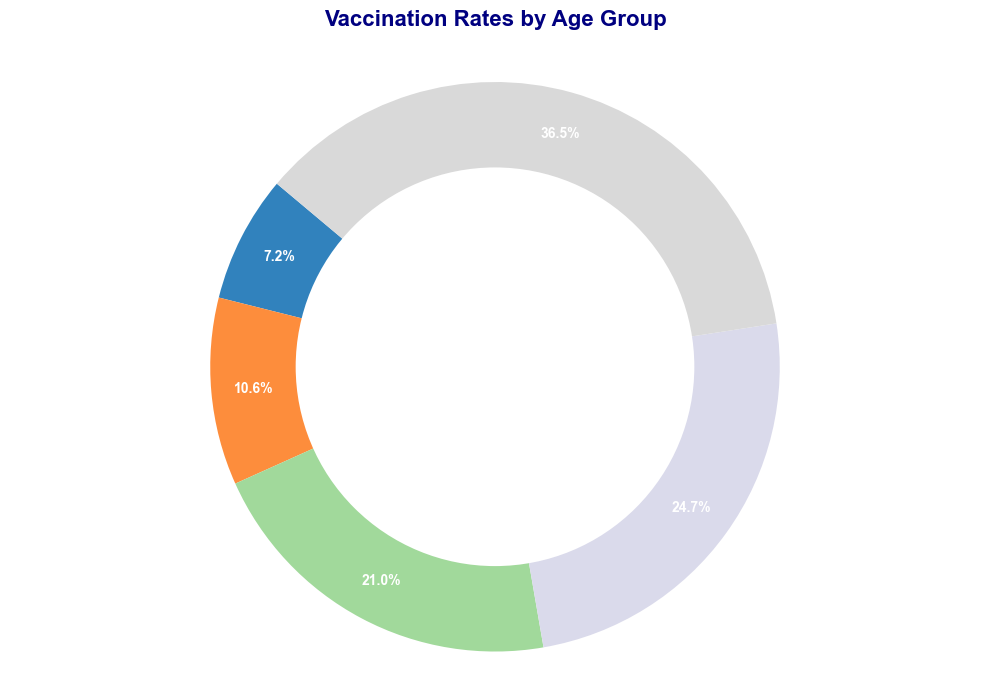What percentage of the total vaccinations is accounted for by the 65+ age group? From the pie chart, the "65+" age group is a slice of the pie representing their vaccination rate. This percentage is labeled directly on the chart.
Answer: 25.2% How does the vaccination rate of the 30-49 age group compare to the 50-64 age group? Refer to the pie chart where both age groups are represented. The percentage of the total vaccinations for each group is labeled, allowing for a direct comparison.
Answer: 20.8% vs. 24.9% Which age group has the smallest share of the total vaccination rates? By observing the pie chart, the age group with the smallest slice is easily identifiable.
Answer: 0-17 What is the combined percentage of total vaccinations for the two lowest age groups (0-17 and 18-29)? Sum the percentages labeled on the pie chart for the "0-17" and "18-29" age groups to get the combined percentage.
Answer: 21.7% How much larger is the vaccination share of the 65+ age group compared to that of the 0-17 age group? Subtract the labeled percentage of the "0-17" age group from that of the "65+" age group to get the difference.
Answer: 17.9% Is the vaccination rate higher in the middle socioeconomic group or the high socioeconomic group for the 30-49 age category? The pie chart provides data for overall age group percentages, but cannot directly answer this specific comparison within an age group. Instead, refer to the provided numerical data: 12.3% for middle vs. 15.4% for high.
Answer: High What color represents the age group with the highest percentage of total vaccinations? Observe the color assigned to the largest slice on the pie chart, which is labeled with the percentage.
Answer: Likely a specific unique color (e.g., navy or a specific segment color) Which age group has almost double the vaccination rate of the 18-29 age group? Compare the labeled percentages for each age group. The "65+" group has a significantly higher percentage, approximately double that of "18-29".
Answer: 65+ What is the percentage difference between the 50-64 and the 30-49 age group vaccination rates? Subtract the percentage of the "30-49" age group from that of the "50-64" age group by referring to the pie chart labels.
Answer: 4.1% Which two age groups have the closest vaccination rates, based on the pie chart? Compare the labeled percentages for each slice on the pie chart to determine which two are closest in value.
Answer: 0-17 and 18-29 